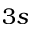<formula> <loc_0><loc_0><loc_500><loc_500>3 s</formula> 